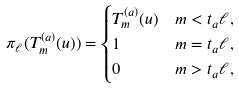<formula> <loc_0><loc_0><loc_500><loc_500>\pi _ { \ell } ( T ^ { ( a ) } _ { m } ( u ) ) & = \begin{cases} T ^ { ( a ) } _ { m } ( u ) & m < t _ { a } \ell , \\ 1 & m = t _ { a } \ell , \\ 0 & m > t _ { a } \ell , \\ \end{cases}</formula> 